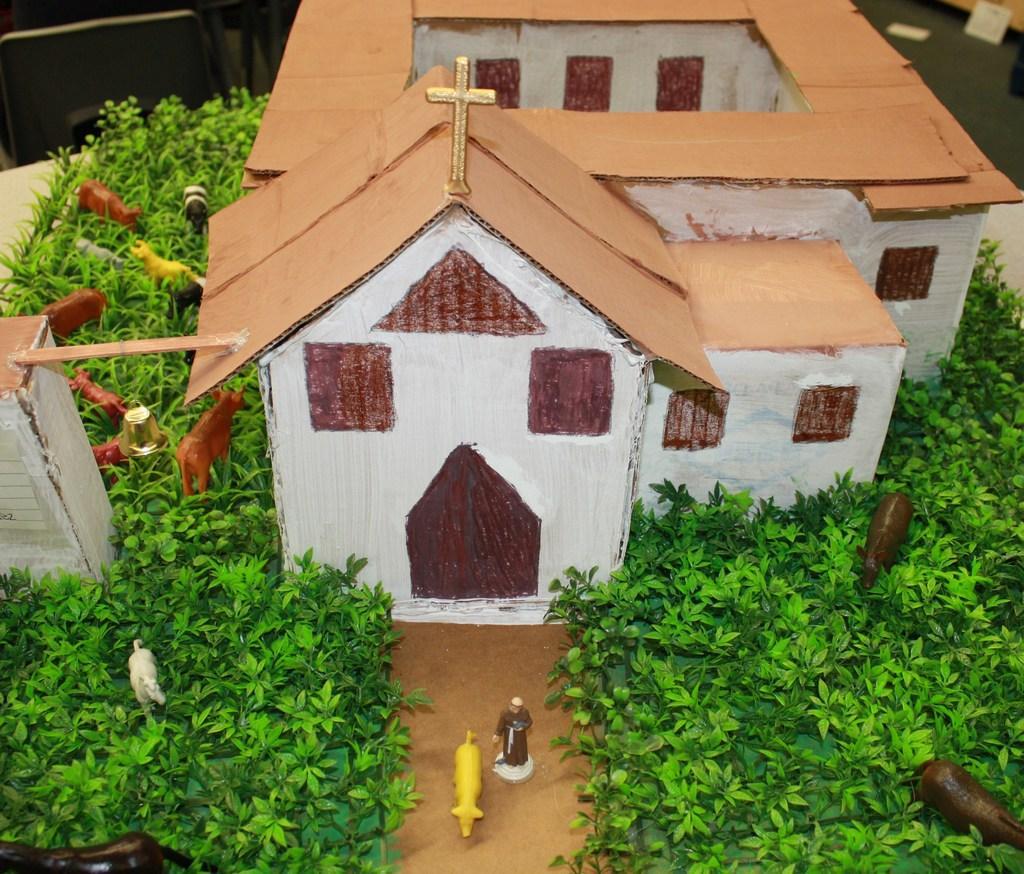Please provide a concise description of this image. In the center of the image, we can see a house made with cardboard and in the background, there are artificial animals and plants. 